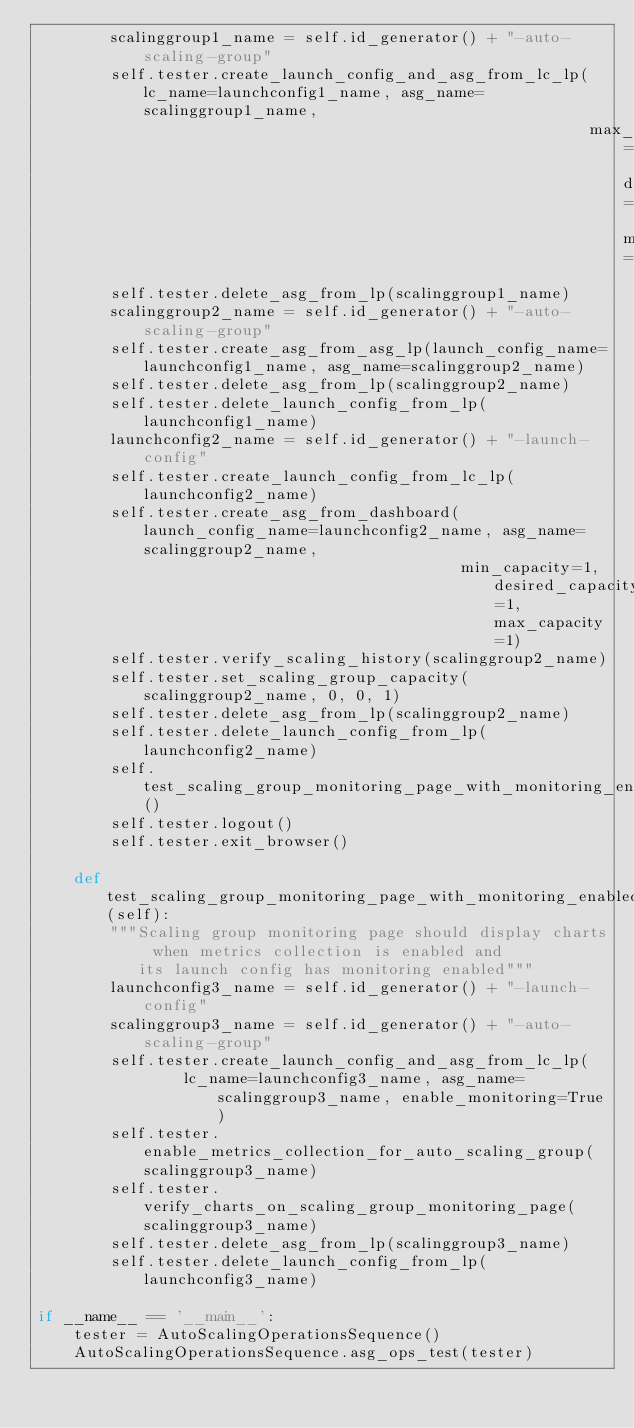Convert code to text. <code><loc_0><loc_0><loc_500><loc_500><_Python_>        scalinggroup1_name = self.id_generator() + "-auto-scaling-group"
        self.tester.create_launch_config_and_asg_from_lc_lp(lc_name=launchconfig1_name, asg_name=scalinggroup1_name,
                                                            max_capacity=2, desired_capacity=1, min_cpapacity=0)
        self.tester.delete_asg_from_lp(scalinggroup1_name)
        scalinggroup2_name = self.id_generator() + "-auto-scaling-group"
        self.tester.create_asg_from_asg_lp(launch_config_name=launchconfig1_name, asg_name=scalinggroup2_name)
        self.tester.delete_asg_from_lp(scalinggroup2_name)
        self.tester.delete_launch_config_from_lp(launchconfig1_name)
        launchconfig2_name = self.id_generator() + "-launch-config"
        self.tester.create_launch_config_from_lc_lp(launchconfig2_name)
        self.tester.create_asg_from_dashboard(launch_config_name=launchconfig2_name, asg_name=scalinggroup2_name,
                                              min_capacity=1, desired_capacity=1, max_capacity=1)
        self.tester.verify_scaling_history(scalinggroup2_name)
        self.tester.set_scaling_group_capacity(scalinggroup2_name, 0, 0, 1)
        self.tester.delete_asg_from_lp(scalinggroup2_name)
        self.tester.delete_launch_config_from_lp(launchconfig2_name)
        self.test_scaling_group_monitoring_page_with_monitoring_enabled()
        self.tester.logout()
        self.tester.exit_browser()

    def test_scaling_group_monitoring_page_with_monitoring_enabled(self):
        """Scaling group monitoring page should display charts when metrics collection is enabled and
           its launch config has monitoring enabled"""
        launchconfig3_name = self.id_generator() + "-launch-config"
        scalinggroup3_name = self.id_generator() + "-auto-scaling-group"
        self.tester.create_launch_config_and_asg_from_lc_lp(
                lc_name=launchconfig3_name, asg_name=scalinggroup3_name, enable_monitoring=True)
        self.tester.enable_metrics_collection_for_auto_scaling_group(scalinggroup3_name)
        self.tester.verify_charts_on_scaling_group_monitoring_page(scalinggroup3_name)
        self.tester.delete_asg_from_lp(scalinggroup3_name)
        self.tester.delete_launch_config_from_lp(launchconfig3_name)

if __name__ == '__main__':
    tester = AutoScalingOperationsSequence()
    AutoScalingOperationsSequence.asg_ops_test(tester)
</code> 